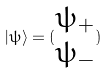Convert formula to latex. <formula><loc_0><loc_0><loc_500><loc_500>| \psi \rangle = ( \begin{matrix} \psi _ { + } \\ \psi _ { - } \end{matrix} )</formula> 